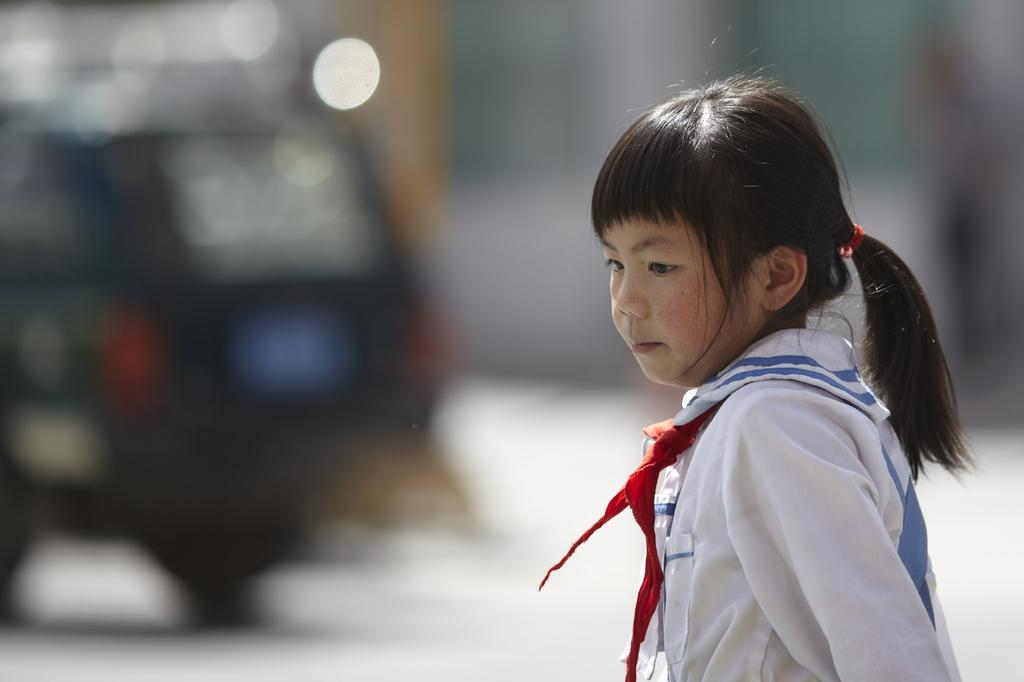Who is the main subject in the image? There is a girl in the image. Where is the girl positioned in the image? The girl is in the front of the image. What can be seen on the left side of the image? There is a vehicle on the left side of the image. How would you describe the background of the image? The background of the image is blurry. What type of cracker is the girl eating in the image? There is no cracker present in the image, and the girl is not eating anything. 